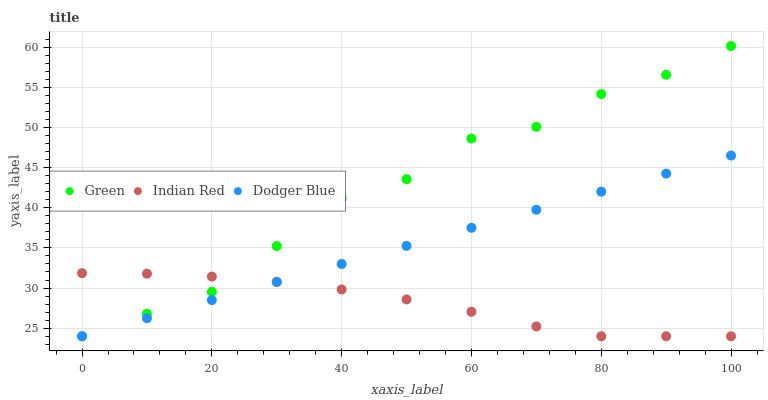Does Indian Red have the minimum area under the curve?
Answer yes or no. Yes. Does Green have the maximum area under the curve?
Answer yes or no. Yes. Does Green have the minimum area under the curve?
Answer yes or no. No. Does Indian Red have the maximum area under the curve?
Answer yes or no. No. Is Dodger Blue the smoothest?
Answer yes or no. Yes. Is Green the roughest?
Answer yes or no. Yes. Is Indian Red the smoothest?
Answer yes or no. No. Is Indian Red the roughest?
Answer yes or no. No. Does Dodger Blue have the lowest value?
Answer yes or no. Yes. Does Green have the highest value?
Answer yes or no. Yes. Does Indian Red have the highest value?
Answer yes or no. No. Does Green intersect Dodger Blue?
Answer yes or no. Yes. Is Green less than Dodger Blue?
Answer yes or no. No. Is Green greater than Dodger Blue?
Answer yes or no. No. 